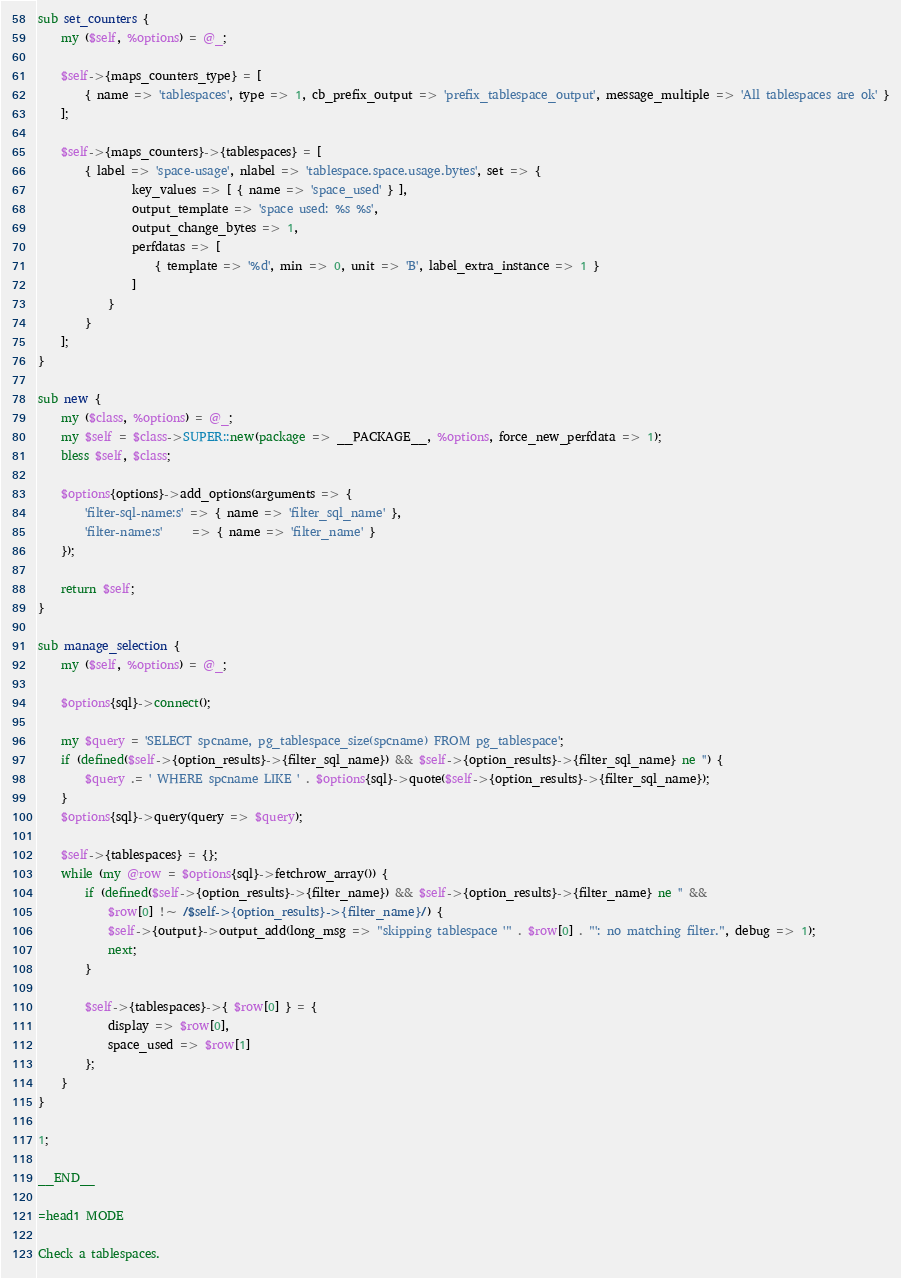<code> <loc_0><loc_0><loc_500><loc_500><_Perl_>sub set_counters {
    my ($self, %options) = @_;

    $self->{maps_counters_type} = [
        { name => 'tablespaces', type => 1, cb_prefix_output => 'prefix_tablespace_output', message_multiple => 'All tablespaces are ok' }
    ];

    $self->{maps_counters}->{tablespaces} = [
        { label => 'space-usage', nlabel => 'tablespace.space.usage.bytes', set => {
                key_values => [ { name => 'space_used' } ],
                output_template => 'space used: %s %s',
                output_change_bytes => 1,
                perfdatas => [
                    { template => '%d', min => 0, unit => 'B', label_extra_instance => 1 }
                ]
            }
        }
    ];
}

sub new {
    my ($class, %options) = @_;
    my $self = $class->SUPER::new(package => __PACKAGE__, %options, force_new_perfdata => 1);
    bless $self, $class;
    
    $options{options}->add_options(arguments => {
        'filter-sql-name:s' => { name => 'filter_sql_name' },
        'filter-name:s'     => { name => 'filter_name' }
    });
    
    return $self;
}

sub manage_selection {
    my ($self, %options) = @_;

    $options{sql}->connect();

    my $query = 'SELECT spcname, pg_tablespace_size(spcname) FROM pg_tablespace';
    if (defined($self->{option_results}->{filter_sql_name}) && $self->{option_results}->{filter_sql_name} ne '') {
        $query .= ' WHERE spcname LIKE ' . $options{sql}->quote($self->{option_results}->{filter_sql_name});
    }
    $options{sql}->query(query => $query);

    $self->{tablespaces} = {};
    while (my @row = $options{sql}->fetchrow_array()) {
        if (defined($self->{option_results}->{filter_name}) && $self->{option_results}->{filter_name} ne '' &&
            $row[0] !~ /$self->{option_results}->{filter_name}/) {
            $self->{output}->output_add(long_msg => "skipping tablespace '" . $row[0] . "': no matching filter.", debug => 1);
            next;
        }

        $self->{tablespaces}->{ $row[0] } = {
            display => $row[0],
            space_used => $row[1]
        };
    }
}

1;

__END__

=head1 MODE

Check a tablespaces.
</code> 